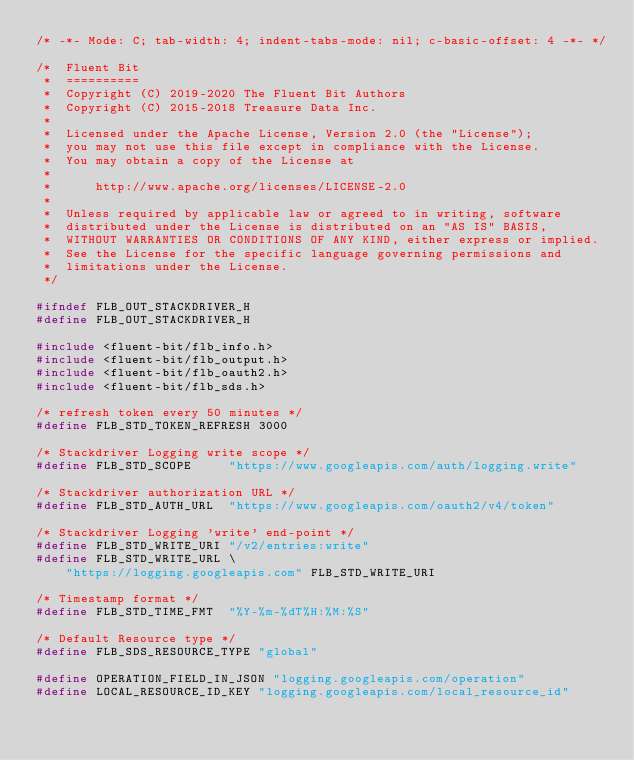Convert code to text. <code><loc_0><loc_0><loc_500><loc_500><_C_>/* -*- Mode: C; tab-width: 4; indent-tabs-mode: nil; c-basic-offset: 4 -*- */

/*  Fluent Bit
 *  ==========
 *  Copyright (C) 2019-2020 The Fluent Bit Authors
 *  Copyright (C) 2015-2018 Treasure Data Inc.
 *
 *  Licensed under the Apache License, Version 2.0 (the "License");
 *  you may not use this file except in compliance with the License.
 *  You may obtain a copy of the License at
 *
 *      http://www.apache.org/licenses/LICENSE-2.0
 *
 *  Unless required by applicable law or agreed to in writing, software
 *  distributed under the License is distributed on an "AS IS" BASIS,
 *  WITHOUT WARRANTIES OR CONDITIONS OF ANY KIND, either express or implied.
 *  See the License for the specific language governing permissions and
 *  limitations under the License.
 */

#ifndef FLB_OUT_STACKDRIVER_H
#define FLB_OUT_STACKDRIVER_H

#include <fluent-bit/flb_info.h>
#include <fluent-bit/flb_output.h>
#include <fluent-bit/flb_oauth2.h>
#include <fluent-bit/flb_sds.h>

/* refresh token every 50 minutes */
#define FLB_STD_TOKEN_REFRESH 3000

/* Stackdriver Logging write scope */
#define FLB_STD_SCOPE     "https://www.googleapis.com/auth/logging.write"

/* Stackdriver authorization URL */
#define FLB_STD_AUTH_URL  "https://www.googleapis.com/oauth2/v4/token"

/* Stackdriver Logging 'write' end-point */
#define FLB_STD_WRITE_URI "/v2/entries:write"
#define FLB_STD_WRITE_URL \
    "https://logging.googleapis.com" FLB_STD_WRITE_URI

/* Timestamp format */
#define FLB_STD_TIME_FMT  "%Y-%m-%dT%H:%M:%S"

/* Default Resource type */
#define FLB_SDS_RESOURCE_TYPE "global"

#define OPERATION_FIELD_IN_JSON "logging.googleapis.com/operation"
#define LOCAL_RESOURCE_ID_KEY "logging.googleapis.com/local_resource_id"</code> 